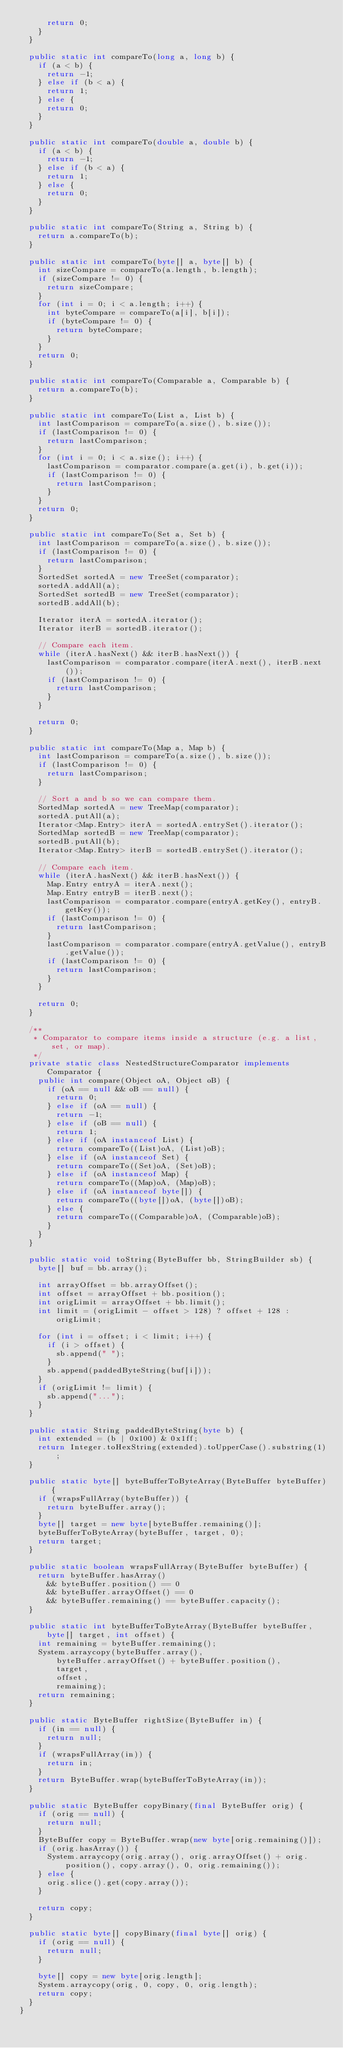Convert code to text. <code><loc_0><loc_0><loc_500><loc_500><_Java_>      return 0;
    }
  }

  public static int compareTo(long a, long b) {
    if (a < b) {
      return -1;
    } else if (b < a) {
      return 1;
    } else {
      return 0;
    }
  }

  public static int compareTo(double a, double b) {
    if (a < b) {
      return -1;
    } else if (b < a) {
      return 1;
    } else {
      return 0;
    }
  }

  public static int compareTo(String a, String b) {
    return a.compareTo(b);
  }

  public static int compareTo(byte[] a, byte[] b) {
    int sizeCompare = compareTo(a.length, b.length);
    if (sizeCompare != 0) {
      return sizeCompare;
    }
    for (int i = 0; i < a.length; i++) {
      int byteCompare = compareTo(a[i], b[i]);
      if (byteCompare != 0) {
        return byteCompare;
      }
    }
    return 0;
  }

  public static int compareTo(Comparable a, Comparable b) {
    return a.compareTo(b);
  }

  public static int compareTo(List a, List b) {
    int lastComparison = compareTo(a.size(), b.size());
    if (lastComparison != 0) {
      return lastComparison;
    }
    for (int i = 0; i < a.size(); i++) {
      lastComparison = comparator.compare(a.get(i), b.get(i));
      if (lastComparison != 0) {
        return lastComparison;
      }
    }
    return 0;
  }

  public static int compareTo(Set a, Set b) {
    int lastComparison = compareTo(a.size(), b.size());
    if (lastComparison != 0) {
      return lastComparison;
    }
    SortedSet sortedA = new TreeSet(comparator);
    sortedA.addAll(a);
    SortedSet sortedB = new TreeSet(comparator);
    sortedB.addAll(b);

    Iterator iterA = sortedA.iterator();
    Iterator iterB = sortedB.iterator();

    // Compare each item.
    while (iterA.hasNext() && iterB.hasNext()) {
      lastComparison = comparator.compare(iterA.next(), iterB.next());
      if (lastComparison != 0) {
        return lastComparison;
      }
    }

    return 0;
  }

  public static int compareTo(Map a, Map b) {
    int lastComparison = compareTo(a.size(), b.size());
    if (lastComparison != 0) {
      return lastComparison;
    }

    // Sort a and b so we can compare them.
    SortedMap sortedA = new TreeMap(comparator);
    sortedA.putAll(a);
    Iterator<Map.Entry> iterA = sortedA.entrySet().iterator();
    SortedMap sortedB = new TreeMap(comparator);
    sortedB.putAll(b);
    Iterator<Map.Entry> iterB = sortedB.entrySet().iterator();

    // Compare each item.
    while (iterA.hasNext() && iterB.hasNext()) {
      Map.Entry entryA = iterA.next();
      Map.Entry entryB = iterB.next();
      lastComparison = comparator.compare(entryA.getKey(), entryB.getKey());
      if (lastComparison != 0) {
        return lastComparison;
      }
      lastComparison = comparator.compare(entryA.getValue(), entryB.getValue());
      if (lastComparison != 0) {
        return lastComparison;
      }
    }

    return 0;
  }

  /**
   * Comparator to compare items inside a structure (e.g. a list, set, or map).
   */
  private static class NestedStructureComparator implements Comparator {
    public int compare(Object oA, Object oB) {
      if (oA == null && oB == null) {
        return 0;
      } else if (oA == null) {
        return -1;
      } else if (oB == null) {
        return 1;
      } else if (oA instanceof List) {
        return compareTo((List)oA, (List)oB);
      } else if (oA instanceof Set) {
        return compareTo((Set)oA, (Set)oB);
      } else if (oA instanceof Map) {
        return compareTo((Map)oA, (Map)oB);
      } else if (oA instanceof byte[]) {
        return compareTo((byte[])oA, (byte[])oB);
      } else {
        return compareTo((Comparable)oA, (Comparable)oB);
      }
    }
  }

  public static void toString(ByteBuffer bb, StringBuilder sb) {
    byte[] buf = bb.array();

    int arrayOffset = bb.arrayOffset();
    int offset = arrayOffset + bb.position();
    int origLimit = arrayOffset + bb.limit();
    int limit = (origLimit - offset > 128) ? offset + 128 : origLimit;

    for (int i = offset; i < limit; i++) {
      if (i > offset) {
        sb.append(" ");
      }
      sb.append(paddedByteString(buf[i]));
    }
    if (origLimit != limit) {
      sb.append("...");
    }
  }

  public static String paddedByteString(byte b) {
    int extended = (b | 0x100) & 0x1ff;
    return Integer.toHexString(extended).toUpperCase().substring(1);
  }

  public static byte[] byteBufferToByteArray(ByteBuffer byteBuffer) {
    if (wrapsFullArray(byteBuffer)) {
      return byteBuffer.array();
    }
    byte[] target = new byte[byteBuffer.remaining()];
    byteBufferToByteArray(byteBuffer, target, 0);
    return target;
  }

  public static boolean wrapsFullArray(ByteBuffer byteBuffer) {
    return byteBuffer.hasArray()
      && byteBuffer.position() == 0
      && byteBuffer.arrayOffset() == 0
      && byteBuffer.remaining() == byteBuffer.capacity();
  }

  public static int byteBufferToByteArray(ByteBuffer byteBuffer, byte[] target, int offset) {
    int remaining = byteBuffer.remaining();
    System.arraycopy(byteBuffer.array(),
        byteBuffer.arrayOffset() + byteBuffer.position(),
        target,
        offset,
        remaining);
    return remaining;
  }

  public static ByteBuffer rightSize(ByteBuffer in) {
    if (in == null) {
      return null;
    }
    if (wrapsFullArray(in)) {
      return in;
    }
    return ByteBuffer.wrap(byteBufferToByteArray(in));
  }

  public static ByteBuffer copyBinary(final ByteBuffer orig) {
    if (orig == null) {
      return null;
    }
    ByteBuffer copy = ByteBuffer.wrap(new byte[orig.remaining()]);
    if (orig.hasArray()) {
      System.arraycopy(orig.array(), orig.arrayOffset() + orig.position(), copy.array(), 0, orig.remaining());
    } else {
      orig.slice().get(copy.array());
    }

    return copy;
  }

  public static byte[] copyBinary(final byte[] orig) {
    if (orig == null) {
      return null;
    }

    byte[] copy = new byte[orig.length];
    System.arraycopy(orig, 0, copy, 0, orig.length);
    return copy;
  }
}
</code> 